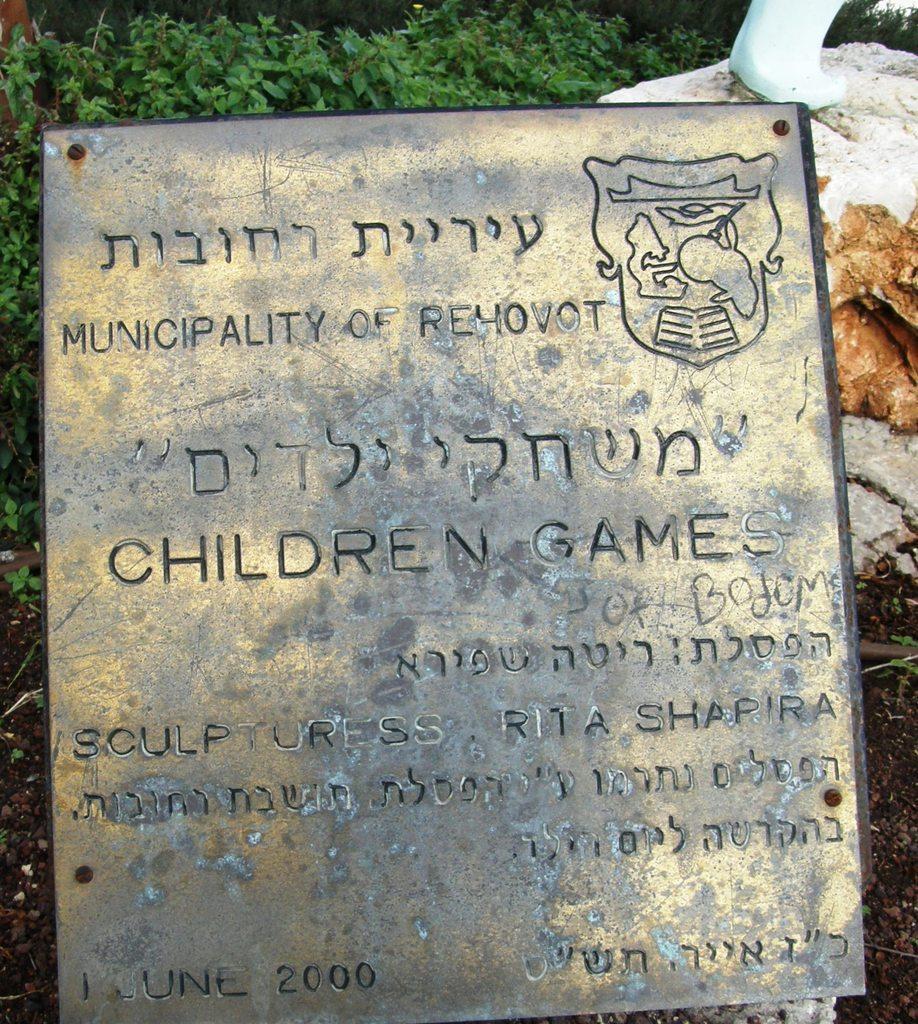In one or two sentences, can you explain what this image depicts? In this image I can see there is a metal frame and there is something written on it, there are few plants in the background, there are rocks at the right side. 